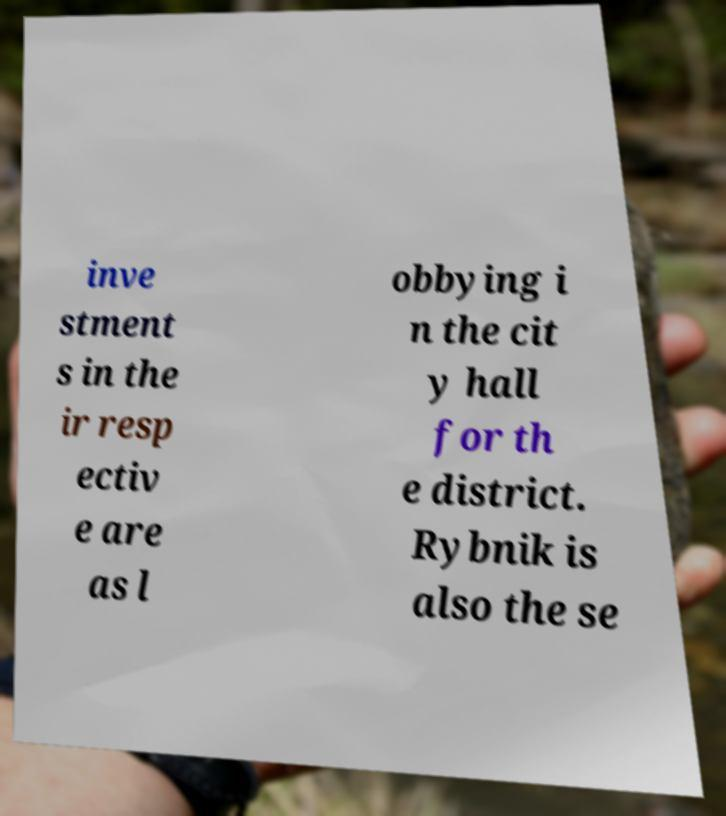Please read and relay the text visible in this image. What does it say? inve stment s in the ir resp ectiv e are as l obbying i n the cit y hall for th e district. Rybnik is also the se 